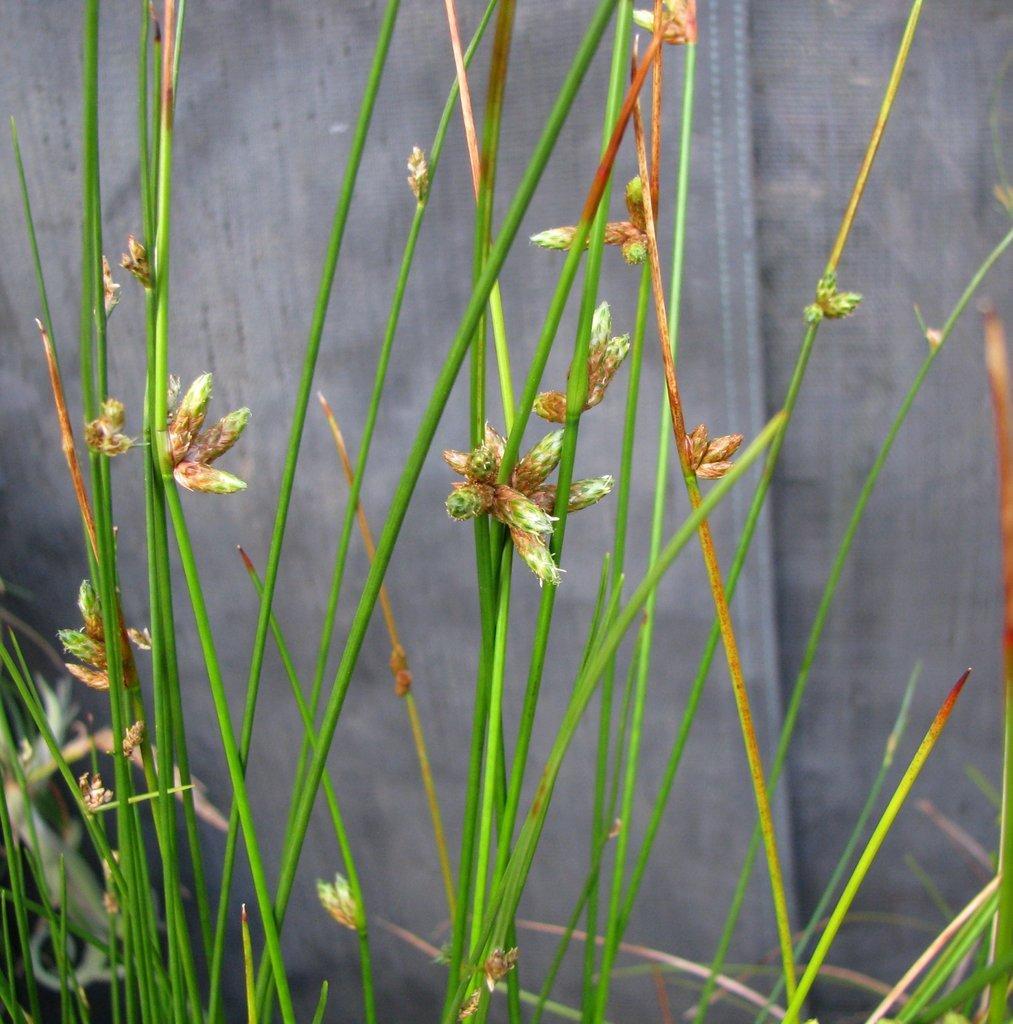Please provide a concise description of this image. In this picture, we see the grass in green color and behind that, we see a wall in grey color. 